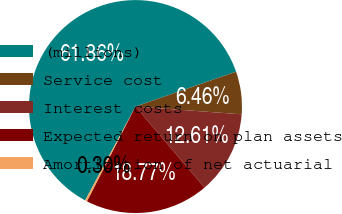<chart> <loc_0><loc_0><loc_500><loc_500><pie_chart><fcel>(millions)<fcel>Service cost<fcel>Interest costs<fcel>Expected return on plan assets<fcel>Amortization of net actuarial<nl><fcel>61.86%<fcel>6.46%<fcel>12.61%<fcel>18.77%<fcel>0.3%<nl></chart> 